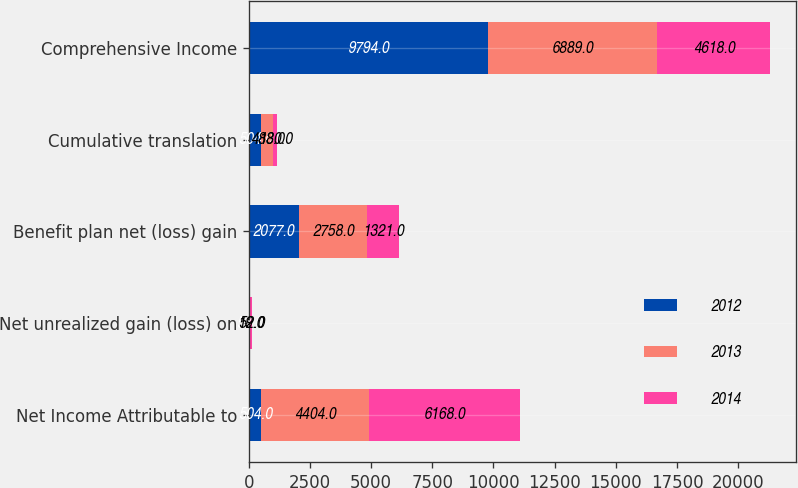Convert chart to OTSL. <chart><loc_0><loc_0><loc_500><loc_500><stacked_bar_chart><ecel><fcel>Net Income Attributable to<fcel>Net unrealized gain (loss) on<fcel>Benefit plan net (loss) gain<fcel>Cumulative translation<fcel>Comprehensive Income<nl><fcel>2012<fcel>504<fcel>57<fcel>2077<fcel>504<fcel>9794<nl><fcel>2013<fcel>4404<fcel>19<fcel>2758<fcel>483<fcel>6889<nl><fcel>2014<fcel>6168<fcel>52<fcel>1321<fcel>180<fcel>4618<nl></chart> 